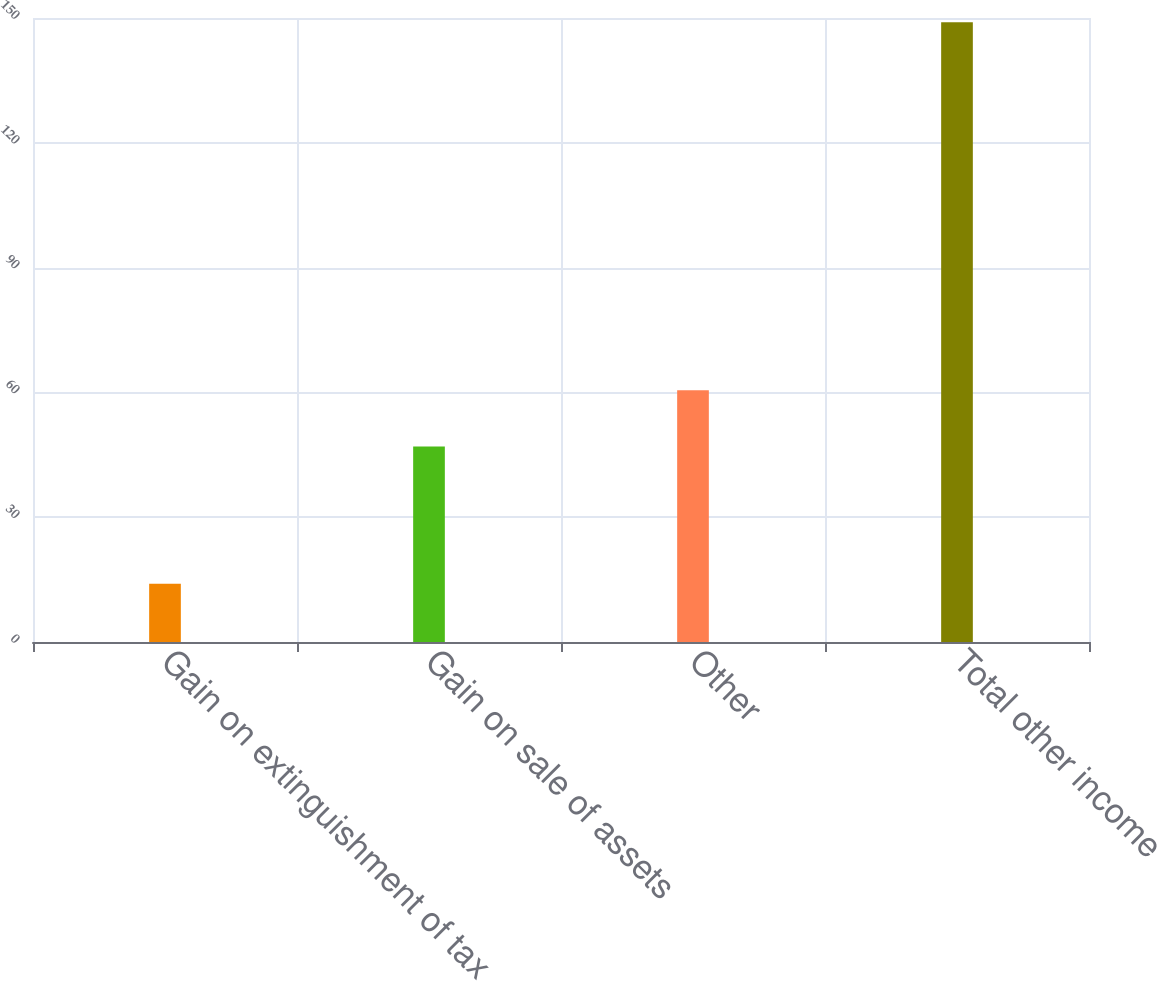Convert chart to OTSL. <chart><loc_0><loc_0><loc_500><loc_500><bar_chart><fcel>Gain on extinguishment of tax<fcel>Gain on sale of assets<fcel>Other<fcel>Total other income<nl><fcel>14<fcel>47<fcel>60.5<fcel>149<nl></chart> 